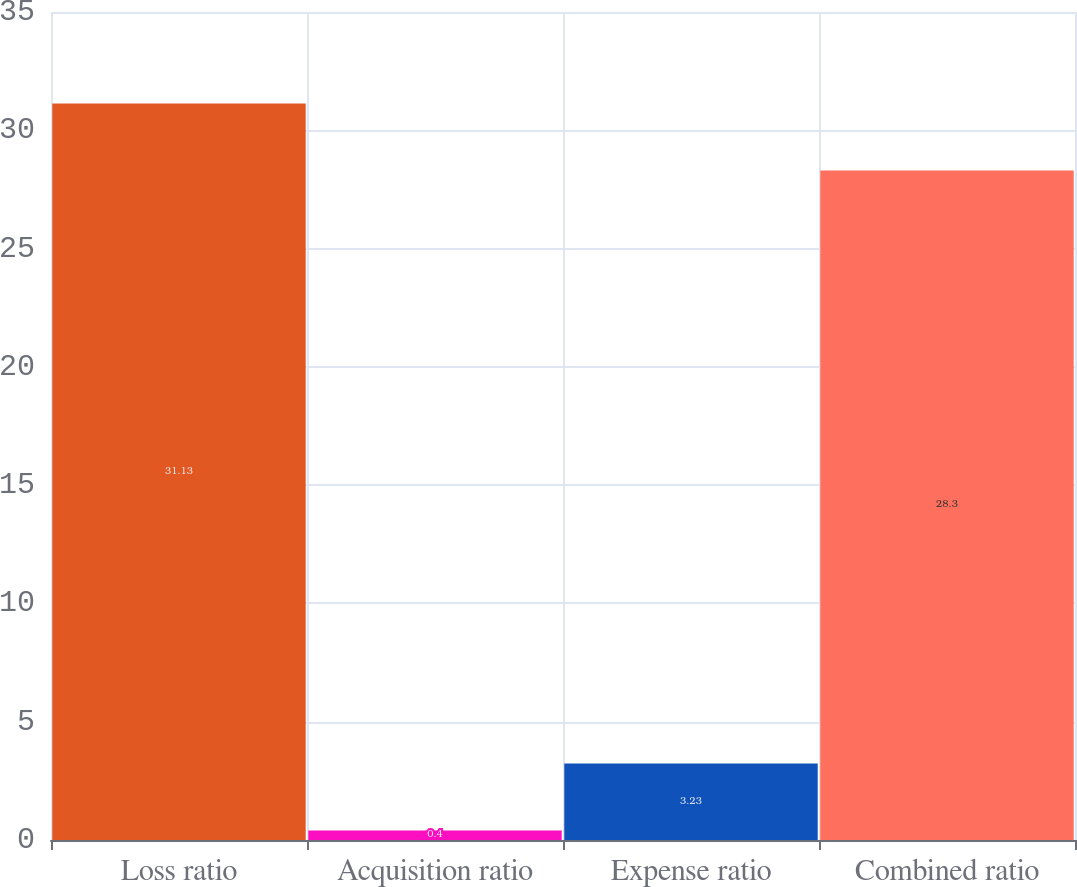Convert chart to OTSL. <chart><loc_0><loc_0><loc_500><loc_500><bar_chart><fcel>Loss ratio<fcel>Acquisition ratio<fcel>Expense ratio<fcel>Combined ratio<nl><fcel>31.13<fcel>0.4<fcel>3.23<fcel>28.3<nl></chart> 